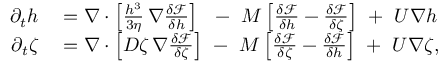<formula> <loc_0><loc_0><loc_500><loc_500>\begin{array} { r l } { \partial _ { t } h } & = \nabla \cdot \left [ \frac { h ^ { 3 } } { 3 \eta } \, \nabla \frac { \delta \mathcal { F } } { \delta h } \right ] \ \ - \ M \left [ \frac { \delta \mathcal { F } } { \delta h } - \frac { \delta \mathcal { F } } { \delta \zeta } \right ] \ + \ U \nabla h } \\ { \partial _ { t } \zeta } & = \nabla \cdot \left [ D \zeta \, \nabla \frac { \delta \mathcal { F } } { \delta \zeta } \right ] \ - \ M \left [ \frac { \delta \mathcal { F } } { \delta \zeta } - \frac { \delta \mathcal { F } } { \delta h } \right ] \ + \ U \nabla \zeta , } \end{array}</formula> 